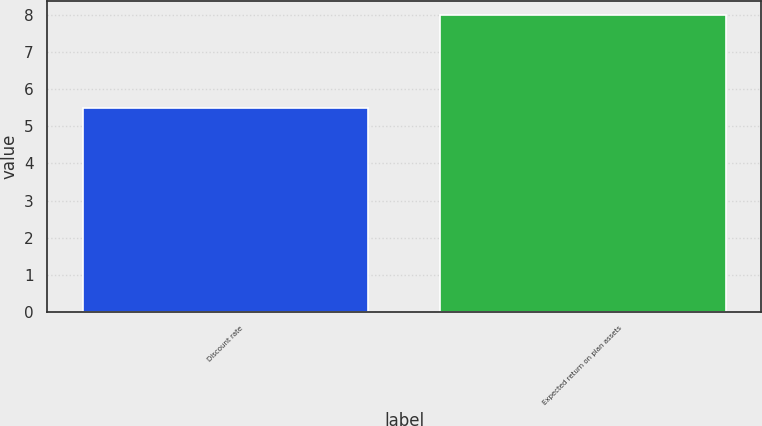Convert chart. <chart><loc_0><loc_0><loc_500><loc_500><bar_chart><fcel>Discount rate<fcel>Expected return on plan assets<nl><fcel>5.5<fcel>8<nl></chart> 